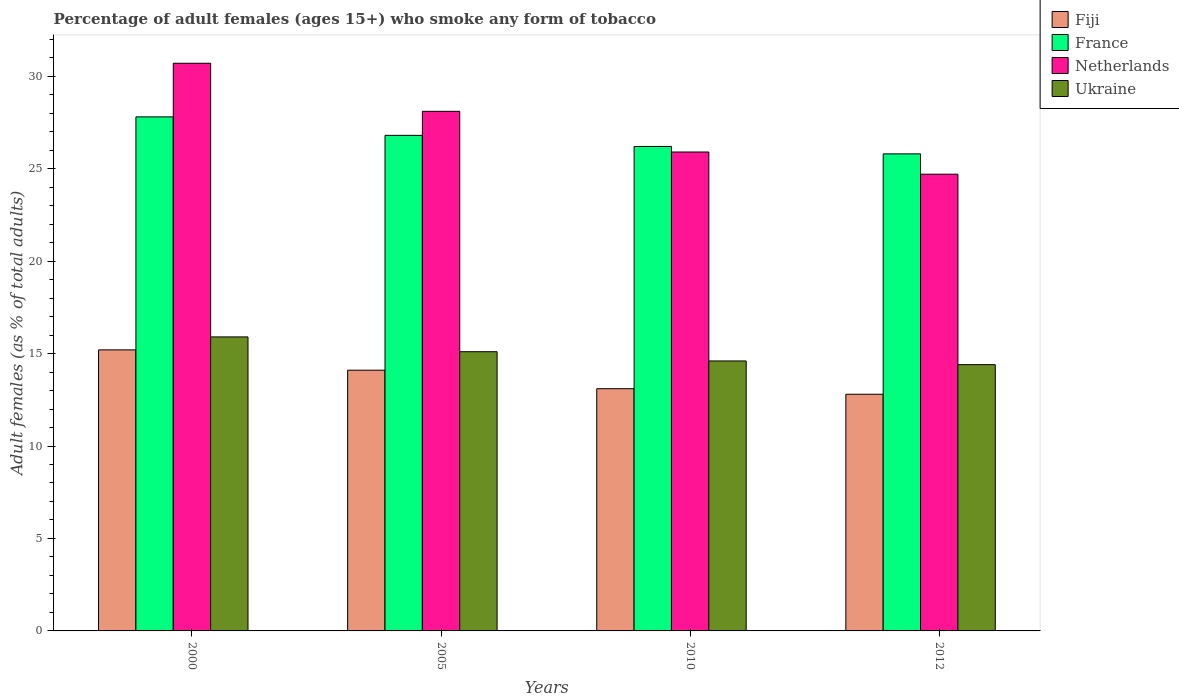Are the number of bars per tick equal to the number of legend labels?
Provide a short and direct response. Yes. Are the number of bars on each tick of the X-axis equal?
Your response must be concise. Yes. How many bars are there on the 2nd tick from the left?
Offer a very short reply. 4. How many bars are there on the 1st tick from the right?
Your answer should be compact. 4. What is the percentage of adult females who smoke in France in 2010?
Your answer should be compact. 26.2. Across all years, what is the maximum percentage of adult females who smoke in France?
Provide a succinct answer. 27.8. Across all years, what is the minimum percentage of adult females who smoke in France?
Your response must be concise. 25.8. In which year was the percentage of adult females who smoke in Ukraine minimum?
Give a very brief answer. 2012. What is the total percentage of adult females who smoke in Fiji in the graph?
Your response must be concise. 55.2. What is the difference between the percentage of adult females who smoke in Ukraine in 2000 and that in 2005?
Your response must be concise. 0.8. What is the difference between the percentage of adult females who smoke in Netherlands in 2010 and the percentage of adult females who smoke in France in 2012?
Keep it short and to the point. 0.1. What is the average percentage of adult females who smoke in Fiji per year?
Ensure brevity in your answer.  13.8. In the year 2010, what is the difference between the percentage of adult females who smoke in Ukraine and percentage of adult females who smoke in France?
Provide a succinct answer. -11.6. In how many years, is the percentage of adult females who smoke in Netherlands greater than 30 %?
Give a very brief answer. 1. What is the ratio of the percentage of adult females who smoke in Netherlands in 2010 to that in 2012?
Provide a short and direct response. 1.05. What does the 3rd bar from the left in 2005 represents?
Offer a terse response. Netherlands. What does the 4th bar from the right in 2000 represents?
Your response must be concise. Fiji. How many bars are there?
Make the answer very short. 16. How many years are there in the graph?
Ensure brevity in your answer.  4. What is the difference between two consecutive major ticks on the Y-axis?
Ensure brevity in your answer.  5. Does the graph contain grids?
Offer a terse response. No. Where does the legend appear in the graph?
Your answer should be very brief. Top right. What is the title of the graph?
Provide a succinct answer. Percentage of adult females (ages 15+) who smoke any form of tobacco. What is the label or title of the X-axis?
Your answer should be very brief. Years. What is the label or title of the Y-axis?
Offer a terse response. Adult females (as % of total adults). What is the Adult females (as % of total adults) of France in 2000?
Keep it short and to the point. 27.8. What is the Adult females (as % of total adults) in Netherlands in 2000?
Make the answer very short. 30.7. What is the Adult females (as % of total adults) in Ukraine in 2000?
Provide a short and direct response. 15.9. What is the Adult females (as % of total adults) of Fiji in 2005?
Make the answer very short. 14.1. What is the Adult females (as % of total adults) of France in 2005?
Your answer should be very brief. 26.8. What is the Adult females (as % of total adults) in Netherlands in 2005?
Offer a terse response. 28.1. What is the Adult females (as % of total adults) in Ukraine in 2005?
Provide a short and direct response. 15.1. What is the Adult females (as % of total adults) in France in 2010?
Provide a short and direct response. 26.2. What is the Adult females (as % of total adults) in Netherlands in 2010?
Provide a succinct answer. 25.9. What is the Adult females (as % of total adults) in Ukraine in 2010?
Provide a short and direct response. 14.6. What is the Adult females (as % of total adults) of France in 2012?
Your answer should be compact. 25.8. What is the Adult females (as % of total adults) of Netherlands in 2012?
Your response must be concise. 24.7. What is the Adult females (as % of total adults) in Ukraine in 2012?
Provide a succinct answer. 14.4. Across all years, what is the maximum Adult females (as % of total adults) of Fiji?
Ensure brevity in your answer.  15.2. Across all years, what is the maximum Adult females (as % of total adults) of France?
Keep it short and to the point. 27.8. Across all years, what is the maximum Adult females (as % of total adults) in Netherlands?
Provide a succinct answer. 30.7. Across all years, what is the minimum Adult females (as % of total adults) of Fiji?
Ensure brevity in your answer.  12.8. Across all years, what is the minimum Adult females (as % of total adults) of France?
Offer a very short reply. 25.8. Across all years, what is the minimum Adult females (as % of total adults) in Netherlands?
Offer a very short reply. 24.7. What is the total Adult females (as % of total adults) in Fiji in the graph?
Keep it short and to the point. 55.2. What is the total Adult females (as % of total adults) of France in the graph?
Offer a terse response. 106.6. What is the total Adult females (as % of total adults) in Netherlands in the graph?
Your response must be concise. 109.4. What is the difference between the Adult females (as % of total adults) of Netherlands in 2000 and that in 2005?
Offer a terse response. 2.6. What is the difference between the Adult females (as % of total adults) of Netherlands in 2000 and that in 2010?
Offer a very short reply. 4.8. What is the difference between the Adult females (as % of total adults) of Ukraine in 2000 and that in 2012?
Offer a terse response. 1.5. What is the difference between the Adult females (as % of total adults) in Fiji in 2005 and that in 2010?
Your response must be concise. 1. What is the difference between the Adult females (as % of total adults) in Fiji in 2005 and that in 2012?
Offer a terse response. 1.3. What is the difference between the Adult females (as % of total adults) of France in 2005 and that in 2012?
Keep it short and to the point. 1. What is the difference between the Adult females (as % of total adults) in Fiji in 2010 and that in 2012?
Your answer should be compact. 0.3. What is the difference between the Adult females (as % of total adults) in Ukraine in 2010 and that in 2012?
Ensure brevity in your answer.  0.2. What is the difference between the Adult females (as % of total adults) of Fiji in 2000 and the Adult females (as % of total adults) of Ukraine in 2005?
Make the answer very short. 0.1. What is the difference between the Adult females (as % of total adults) in France in 2000 and the Adult females (as % of total adults) in Netherlands in 2005?
Make the answer very short. -0.3. What is the difference between the Adult females (as % of total adults) in Fiji in 2000 and the Adult females (as % of total adults) in France in 2010?
Offer a terse response. -11. What is the difference between the Adult females (as % of total adults) in Fiji in 2000 and the Adult females (as % of total adults) in Ukraine in 2010?
Offer a very short reply. 0.6. What is the difference between the Adult females (as % of total adults) of France in 2000 and the Adult females (as % of total adults) of Netherlands in 2010?
Give a very brief answer. 1.9. What is the difference between the Adult females (as % of total adults) of France in 2000 and the Adult females (as % of total adults) of Ukraine in 2010?
Give a very brief answer. 13.2. What is the difference between the Adult females (as % of total adults) in Netherlands in 2000 and the Adult females (as % of total adults) in Ukraine in 2010?
Keep it short and to the point. 16.1. What is the difference between the Adult females (as % of total adults) in Fiji in 2000 and the Adult females (as % of total adults) in France in 2012?
Your answer should be compact. -10.6. What is the difference between the Adult females (as % of total adults) of Fiji in 2000 and the Adult females (as % of total adults) of Netherlands in 2012?
Provide a succinct answer. -9.5. What is the difference between the Adult females (as % of total adults) of France in 2000 and the Adult females (as % of total adults) of Netherlands in 2012?
Your answer should be compact. 3.1. What is the difference between the Adult females (as % of total adults) in France in 2000 and the Adult females (as % of total adults) in Ukraine in 2012?
Make the answer very short. 13.4. What is the difference between the Adult females (as % of total adults) of Netherlands in 2000 and the Adult females (as % of total adults) of Ukraine in 2012?
Offer a very short reply. 16.3. What is the difference between the Adult females (as % of total adults) in Fiji in 2005 and the Adult females (as % of total adults) in France in 2010?
Your answer should be compact. -12.1. What is the difference between the Adult females (as % of total adults) of France in 2005 and the Adult females (as % of total adults) of Netherlands in 2010?
Offer a terse response. 0.9. What is the difference between the Adult females (as % of total adults) of Fiji in 2005 and the Adult females (as % of total adults) of France in 2012?
Provide a succinct answer. -11.7. What is the difference between the Adult females (as % of total adults) in Fiji in 2005 and the Adult females (as % of total adults) in Ukraine in 2012?
Ensure brevity in your answer.  -0.3. What is the difference between the Adult females (as % of total adults) in France in 2005 and the Adult females (as % of total adults) in Netherlands in 2012?
Make the answer very short. 2.1. What is the difference between the Adult females (as % of total adults) in France in 2005 and the Adult females (as % of total adults) in Ukraine in 2012?
Keep it short and to the point. 12.4. What is the difference between the Adult females (as % of total adults) in Fiji in 2010 and the Adult females (as % of total adults) in Netherlands in 2012?
Your answer should be very brief. -11.6. What is the difference between the Adult females (as % of total adults) of France in 2010 and the Adult females (as % of total adults) of Netherlands in 2012?
Keep it short and to the point. 1.5. What is the difference between the Adult females (as % of total adults) of Netherlands in 2010 and the Adult females (as % of total adults) of Ukraine in 2012?
Offer a terse response. 11.5. What is the average Adult females (as % of total adults) of France per year?
Offer a terse response. 26.65. What is the average Adult females (as % of total adults) of Netherlands per year?
Ensure brevity in your answer.  27.35. What is the average Adult females (as % of total adults) of Ukraine per year?
Your answer should be very brief. 15. In the year 2000, what is the difference between the Adult females (as % of total adults) of Fiji and Adult females (as % of total adults) of France?
Give a very brief answer. -12.6. In the year 2000, what is the difference between the Adult females (as % of total adults) of Fiji and Adult females (as % of total adults) of Netherlands?
Offer a very short reply. -15.5. In the year 2000, what is the difference between the Adult females (as % of total adults) of Fiji and Adult females (as % of total adults) of Ukraine?
Offer a very short reply. -0.7. In the year 2000, what is the difference between the Adult females (as % of total adults) of France and Adult females (as % of total adults) of Netherlands?
Make the answer very short. -2.9. In the year 2000, what is the difference between the Adult females (as % of total adults) in France and Adult females (as % of total adults) in Ukraine?
Your response must be concise. 11.9. In the year 2000, what is the difference between the Adult females (as % of total adults) of Netherlands and Adult females (as % of total adults) of Ukraine?
Offer a very short reply. 14.8. In the year 2005, what is the difference between the Adult females (as % of total adults) of Fiji and Adult females (as % of total adults) of Netherlands?
Give a very brief answer. -14. In the year 2005, what is the difference between the Adult females (as % of total adults) in Fiji and Adult females (as % of total adults) in Ukraine?
Provide a succinct answer. -1. In the year 2010, what is the difference between the Adult females (as % of total adults) in Fiji and Adult females (as % of total adults) in Ukraine?
Your response must be concise. -1.5. In the year 2010, what is the difference between the Adult females (as % of total adults) of France and Adult females (as % of total adults) of Netherlands?
Make the answer very short. 0.3. In the year 2010, what is the difference between the Adult females (as % of total adults) of Netherlands and Adult females (as % of total adults) of Ukraine?
Provide a short and direct response. 11.3. In the year 2012, what is the difference between the Adult females (as % of total adults) of Fiji and Adult females (as % of total adults) of Netherlands?
Keep it short and to the point. -11.9. In the year 2012, what is the difference between the Adult females (as % of total adults) of France and Adult females (as % of total adults) of Netherlands?
Make the answer very short. 1.1. What is the ratio of the Adult females (as % of total adults) of Fiji in 2000 to that in 2005?
Your answer should be compact. 1.08. What is the ratio of the Adult females (as % of total adults) in France in 2000 to that in 2005?
Your answer should be very brief. 1.04. What is the ratio of the Adult females (as % of total adults) in Netherlands in 2000 to that in 2005?
Keep it short and to the point. 1.09. What is the ratio of the Adult females (as % of total adults) in Ukraine in 2000 to that in 2005?
Provide a short and direct response. 1.05. What is the ratio of the Adult females (as % of total adults) of Fiji in 2000 to that in 2010?
Offer a terse response. 1.16. What is the ratio of the Adult females (as % of total adults) of France in 2000 to that in 2010?
Give a very brief answer. 1.06. What is the ratio of the Adult females (as % of total adults) of Netherlands in 2000 to that in 2010?
Ensure brevity in your answer.  1.19. What is the ratio of the Adult females (as % of total adults) of Ukraine in 2000 to that in 2010?
Make the answer very short. 1.09. What is the ratio of the Adult females (as % of total adults) of Fiji in 2000 to that in 2012?
Ensure brevity in your answer.  1.19. What is the ratio of the Adult females (as % of total adults) in France in 2000 to that in 2012?
Make the answer very short. 1.08. What is the ratio of the Adult females (as % of total adults) in Netherlands in 2000 to that in 2012?
Keep it short and to the point. 1.24. What is the ratio of the Adult females (as % of total adults) in Ukraine in 2000 to that in 2012?
Offer a terse response. 1.1. What is the ratio of the Adult females (as % of total adults) in Fiji in 2005 to that in 2010?
Your answer should be very brief. 1.08. What is the ratio of the Adult females (as % of total adults) in France in 2005 to that in 2010?
Your answer should be very brief. 1.02. What is the ratio of the Adult females (as % of total adults) in Netherlands in 2005 to that in 2010?
Ensure brevity in your answer.  1.08. What is the ratio of the Adult females (as % of total adults) in Ukraine in 2005 to that in 2010?
Keep it short and to the point. 1.03. What is the ratio of the Adult females (as % of total adults) of Fiji in 2005 to that in 2012?
Give a very brief answer. 1.1. What is the ratio of the Adult females (as % of total adults) in France in 2005 to that in 2012?
Provide a succinct answer. 1.04. What is the ratio of the Adult females (as % of total adults) in Netherlands in 2005 to that in 2012?
Give a very brief answer. 1.14. What is the ratio of the Adult females (as % of total adults) in Ukraine in 2005 to that in 2012?
Provide a succinct answer. 1.05. What is the ratio of the Adult females (as % of total adults) in Fiji in 2010 to that in 2012?
Provide a succinct answer. 1.02. What is the ratio of the Adult females (as % of total adults) of France in 2010 to that in 2012?
Keep it short and to the point. 1.02. What is the ratio of the Adult females (as % of total adults) of Netherlands in 2010 to that in 2012?
Your answer should be compact. 1.05. What is the ratio of the Adult females (as % of total adults) of Ukraine in 2010 to that in 2012?
Provide a succinct answer. 1.01. What is the difference between the highest and the second highest Adult females (as % of total adults) in Fiji?
Make the answer very short. 1.1. What is the difference between the highest and the second highest Adult females (as % of total adults) in France?
Provide a succinct answer. 1. What is the difference between the highest and the second highest Adult females (as % of total adults) in Netherlands?
Offer a terse response. 2.6. What is the difference between the highest and the second highest Adult females (as % of total adults) of Ukraine?
Ensure brevity in your answer.  0.8. What is the difference between the highest and the lowest Adult females (as % of total adults) of Fiji?
Your answer should be very brief. 2.4. What is the difference between the highest and the lowest Adult females (as % of total adults) of Netherlands?
Keep it short and to the point. 6. What is the difference between the highest and the lowest Adult females (as % of total adults) of Ukraine?
Provide a succinct answer. 1.5. 